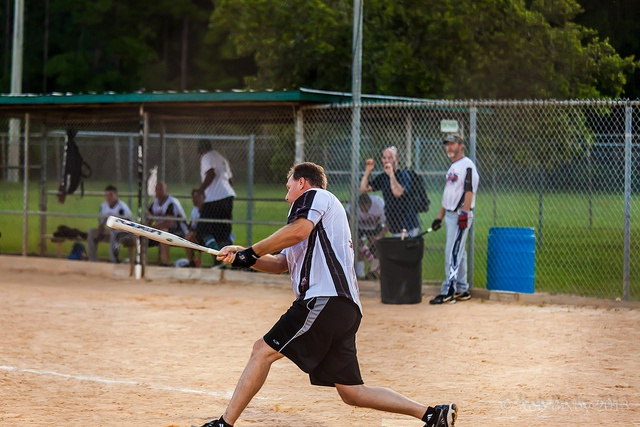Describe the objects in this image and their specific colors. I can see people in black, salmon, and darkgray tones, people in black, darkgray, and gray tones, people in black, gray, and darkgray tones, people in black, gray, and darkgray tones, and people in black and gray tones in this image. 